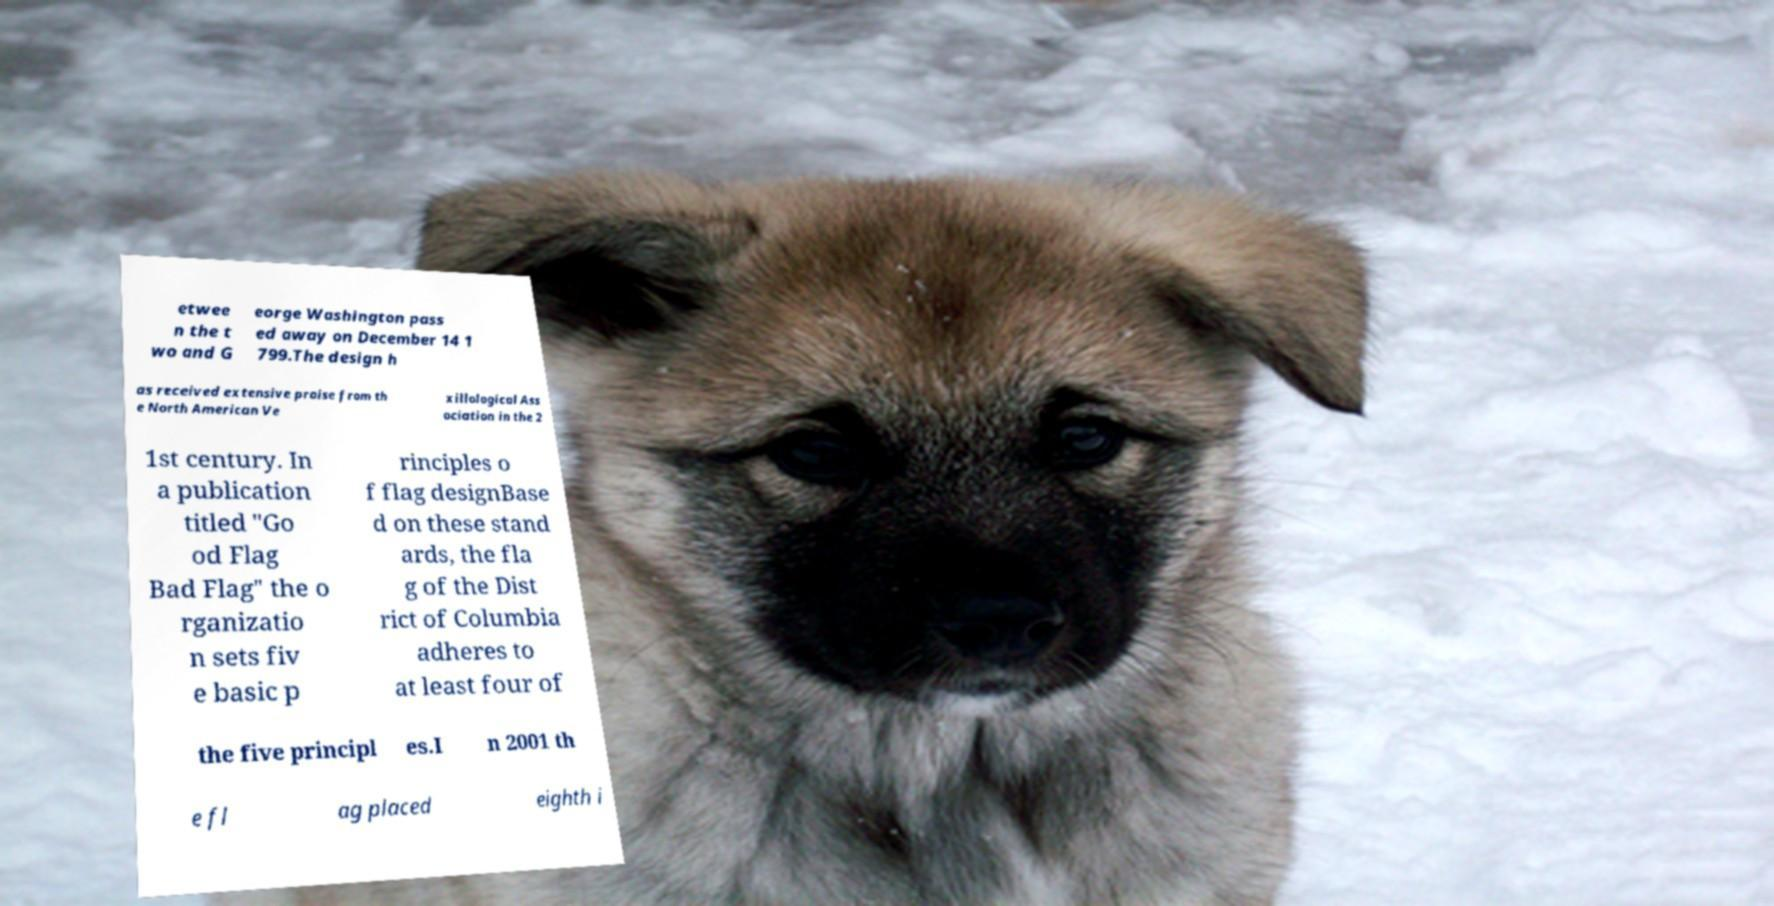What messages or text are displayed in this image? I need them in a readable, typed format. etwee n the t wo and G eorge Washington pass ed away on December 14 1 799.The design h as received extensive praise from th e North American Ve xillological Ass ociation in the 2 1st century. In a publication titled "Go od Flag Bad Flag" the o rganizatio n sets fiv e basic p rinciples o f flag designBase d on these stand ards, the fla g of the Dist rict of Columbia adheres to at least four of the five principl es.I n 2001 th e fl ag placed eighth i 